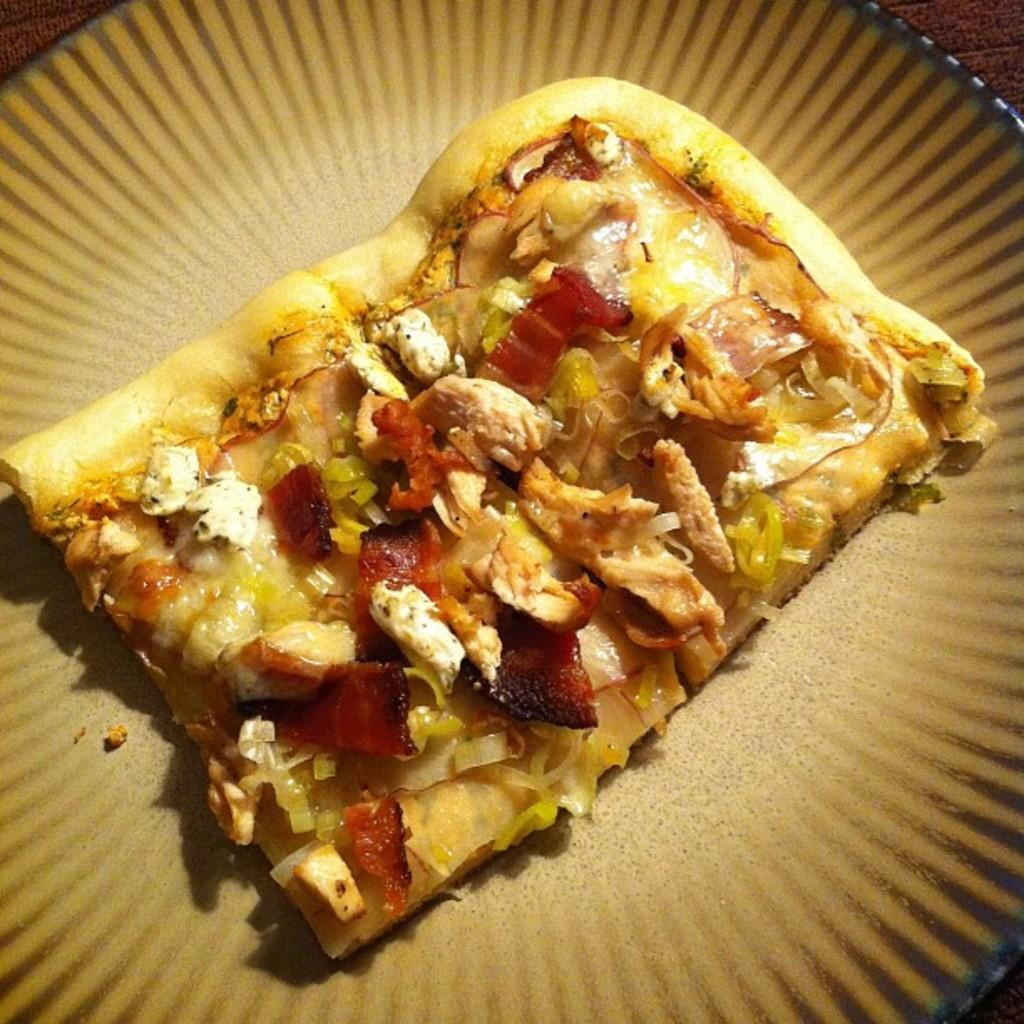What type of food is the main subject of the image? There is a pizza in the image. What toppings can be seen on the pizza? The pizza has vegetable pieces on it. How is the pizza presented in the image? The pizza is on a plate. What is the color of the background in the image? The background color is brown. Can you tell me how many animals are swimming in the territory shown in the image? There are no animals or territory present in the image; it features a pizza with vegetable pieces on it. 